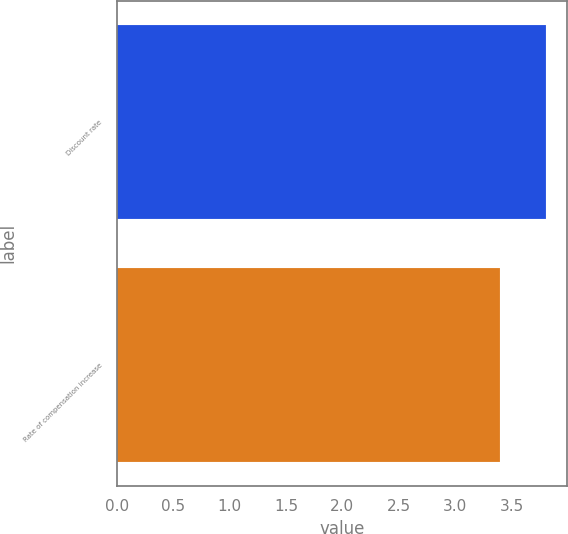Convert chart. <chart><loc_0><loc_0><loc_500><loc_500><bar_chart><fcel>Discount rate<fcel>Rate of compensation increase<nl><fcel>3.8<fcel>3.4<nl></chart> 